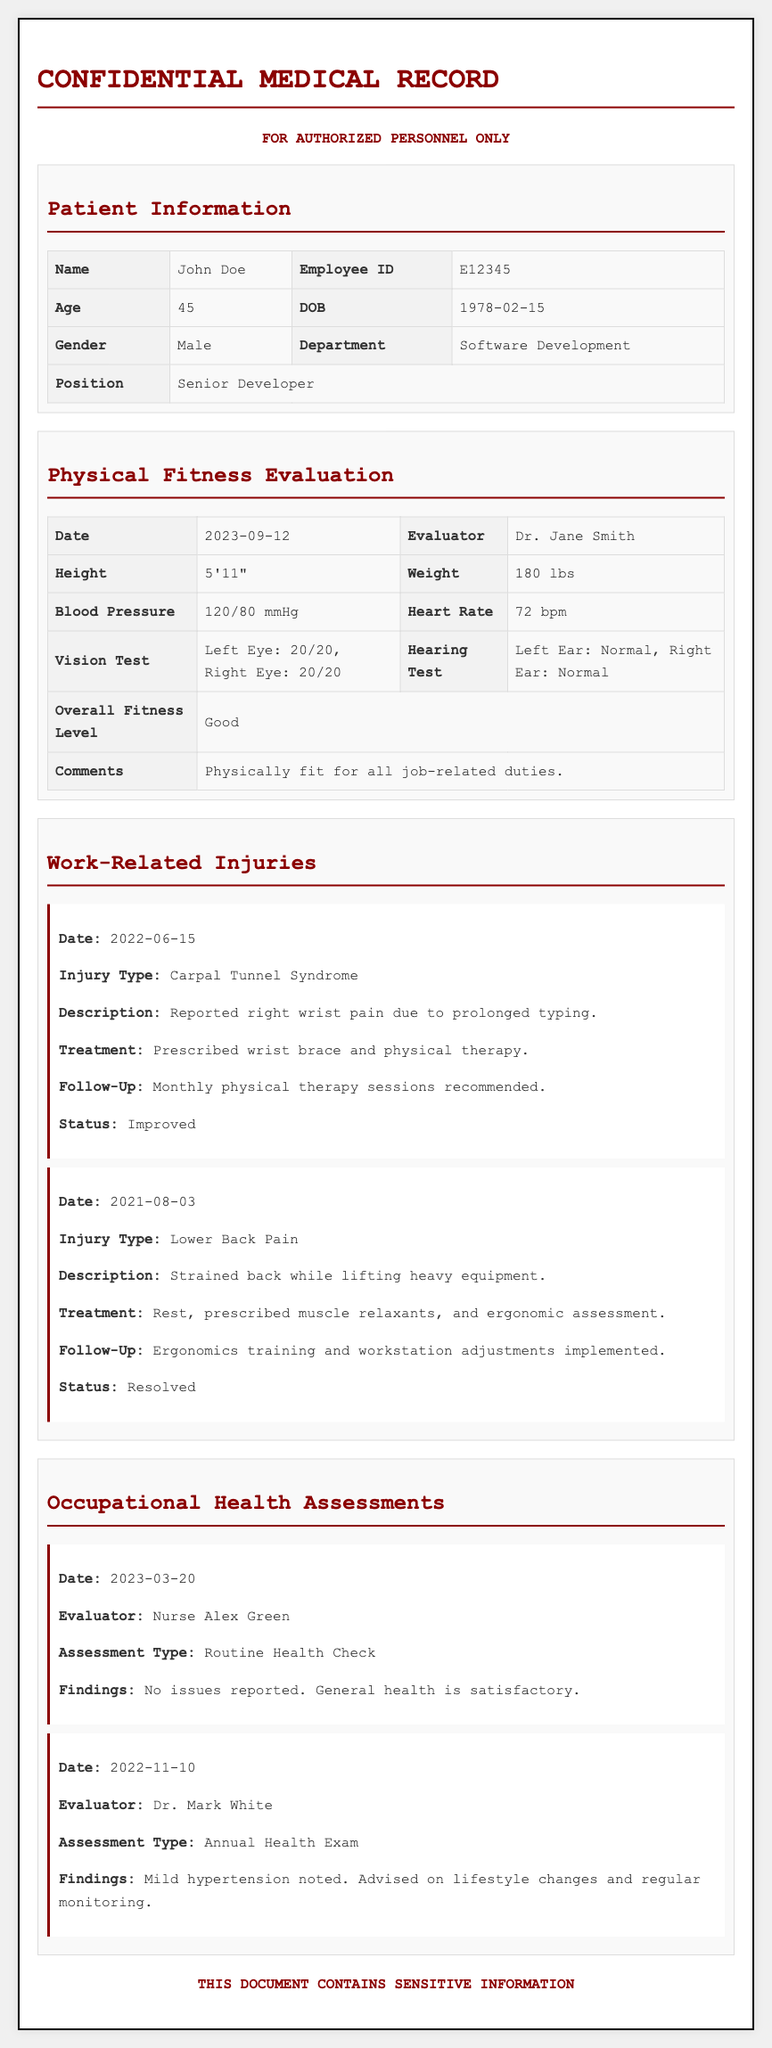What is the patient's name? The patient's name is listed at the top of the document under Patient Information.
Answer: John Doe What is the Evaluator's name for the Physical Fitness Evaluation? The Evaluator's name can be found in the section for the Physical Fitness Evaluation.
Answer: Dr. Jane Smith What type of injury did the patient sustain on June 15, 2022? The type of injury is mentioned in the Work-Related Injuries section, which details the date and nature of the injuries.
Answer: Carpal Tunnel Syndrome What were the findings of the Routine Health Check on March 20, 2023? The findings are stated within the Occupational Health Assessments section, summarizing the results of the assessment.
Answer: No issues reported. General health is satisfactory What treatment was prescribed for the Lower Back Pain? The prescribed treatment is mentioned in the details for the Lower Back Pain injury within the Work-Related Injuries section.
Answer: Rest, prescribed muscle relaxants, and ergonomic assessment What is the age of the patient? The patient's age is provided in the Patient Information section of the document.
Answer: 45 What is the blood pressure reading obtained during the Physical Fitness Evaluation? The blood pressure reading is outlined in the Physical Fitness Evaluation section, detailing vital signs.
Answer: 120/80 mmHg How often are follow-up sessions recommended for the Carpal Tunnel Syndrome? The frequency of follow-up sessions is indicated in the treatment details of the Carpal Tunnel Syndrome entry.
Answer: Monthly What lifestyle changes were advised after the Annual Health Exam? The recommended lifestyle changes are specified in the findings of the Annual Health Exam in the Occupational Health Assessments section.
Answer: Lifestyle changes and regular monitoring 